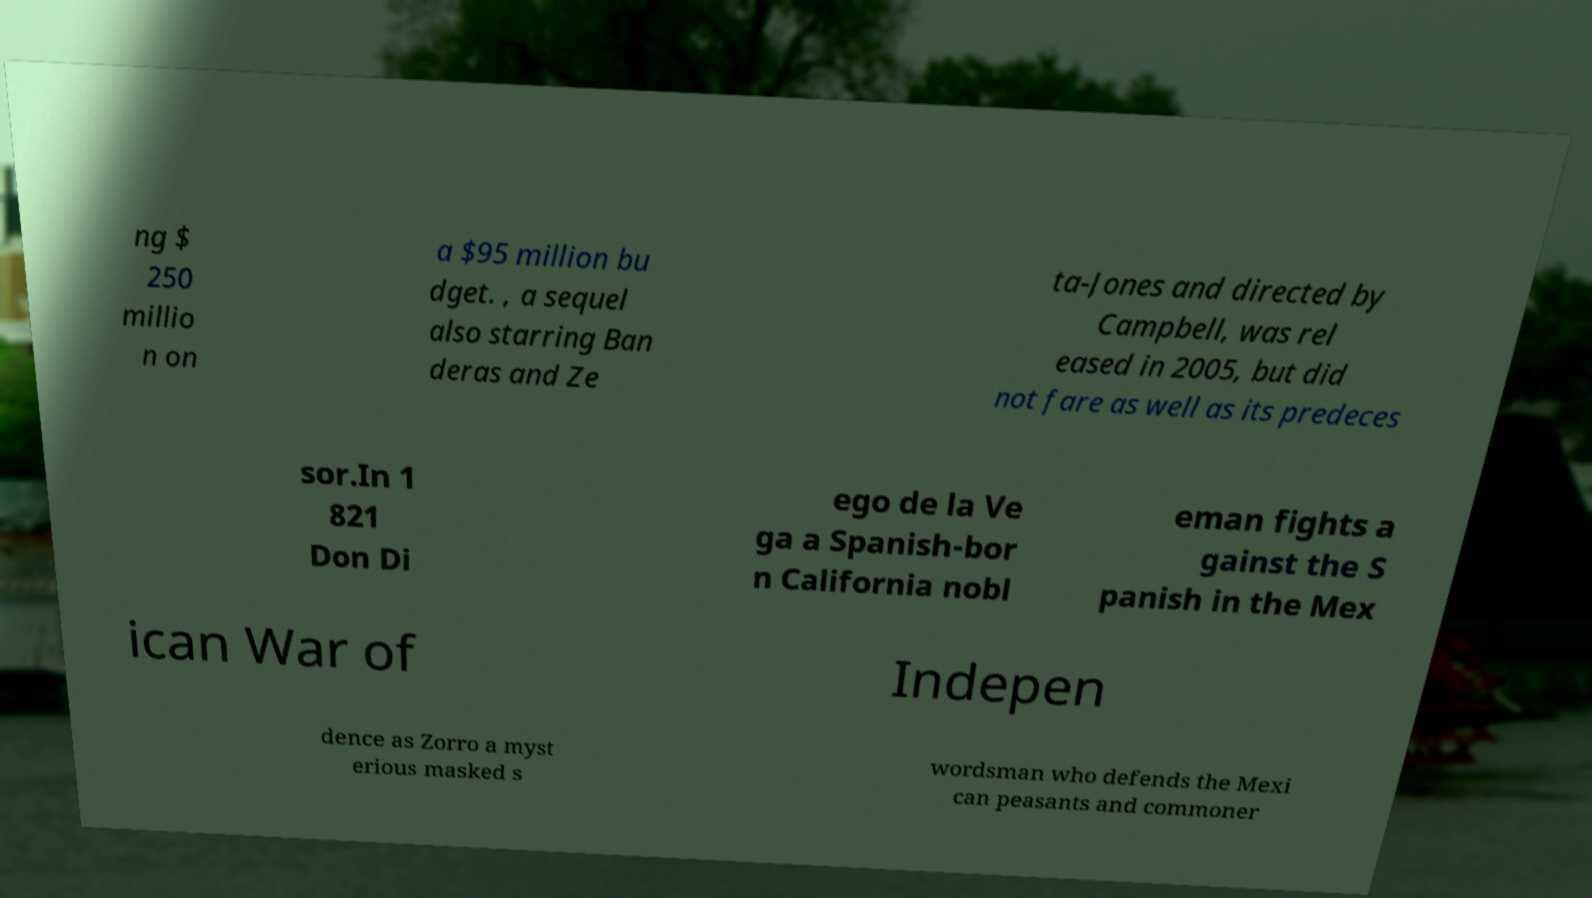I need the written content from this picture converted into text. Can you do that? ng $ 250 millio n on a $95 million bu dget. , a sequel also starring Ban deras and Ze ta-Jones and directed by Campbell, was rel eased in 2005, but did not fare as well as its predeces sor.In 1 821 Don Di ego de la Ve ga a Spanish-bor n California nobl eman fights a gainst the S panish in the Mex ican War of Indepen dence as Zorro a myst erious masked s wordsman who defends the Mexi can peasants and commoner 